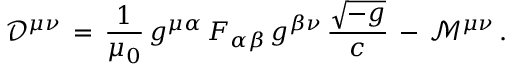<formula> <loc_0><loc_0><loc_500><loc_500>{ \mathcal { D } } ^ { \mu \nu } \, = \, { \frac { 1 } { \mu _ { 0 } } } \, g ^ { \mu \alpha } \, F _ { \alpha \beta } \, g ^ { \beta \nu } \, { \frac { \sqrt { - g } } { c } } \, - \, { \mathcal { M } } ^ { \mu \nu } \, .</formula> 